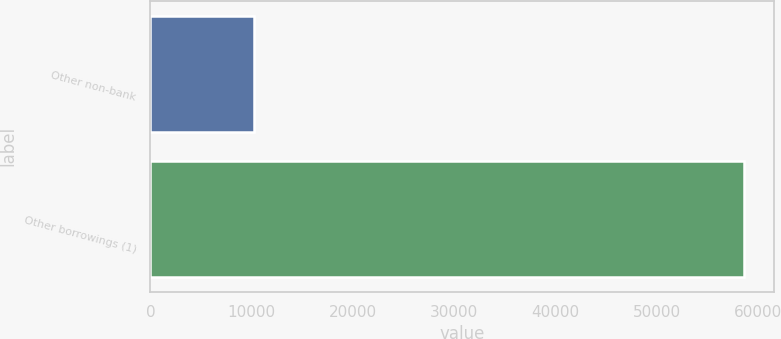Convert chart. <chart><loc_0><loc_0><loc_500><loc_500><bar_chart><fcel>Other non-bank<fcel>Other borrowings (1)<nl><fcel>10223<fcel>58656<nl></chart> 